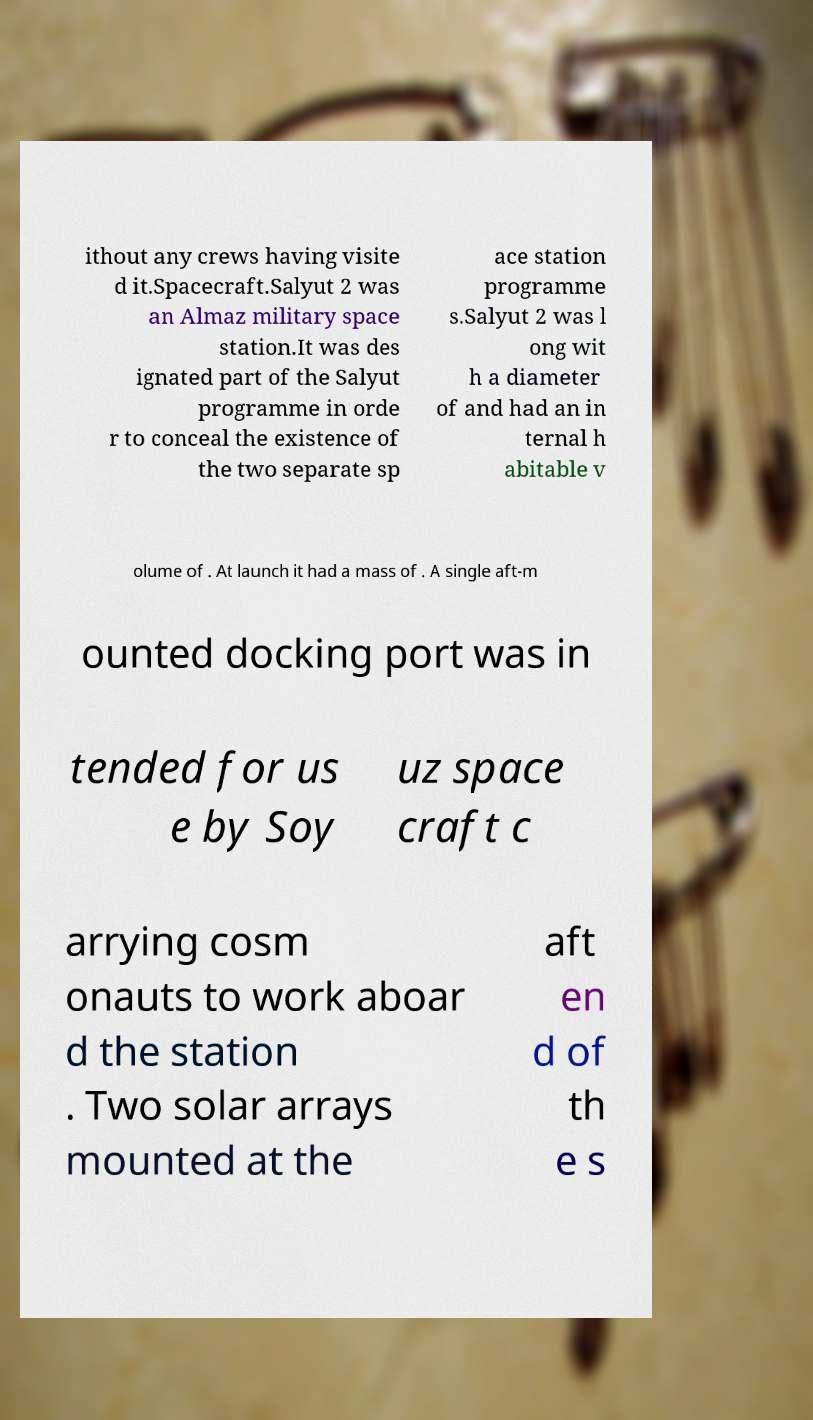Can you read and provide the text displayed in the image?This photo seems to have some interesting text. Can you extract and type it out for me? ithout any crews having visite d it.Spacecraft.Salyut 2 was an Almaz military space station.It was des ignated part of the Salyut programme in orde r to conceal the existence of the two separate sp ace station programme s.Salyut 2 was l ong wit h a diameter of and had an in ternal h abitable v olume of . At launch it had a mass of . A single aft-m ounted docking port was in tended for us e by Soy uz space craft c arrying cosm onauts to work aboar d the station . Two solar arrays mounted at the aft en d of th e s 